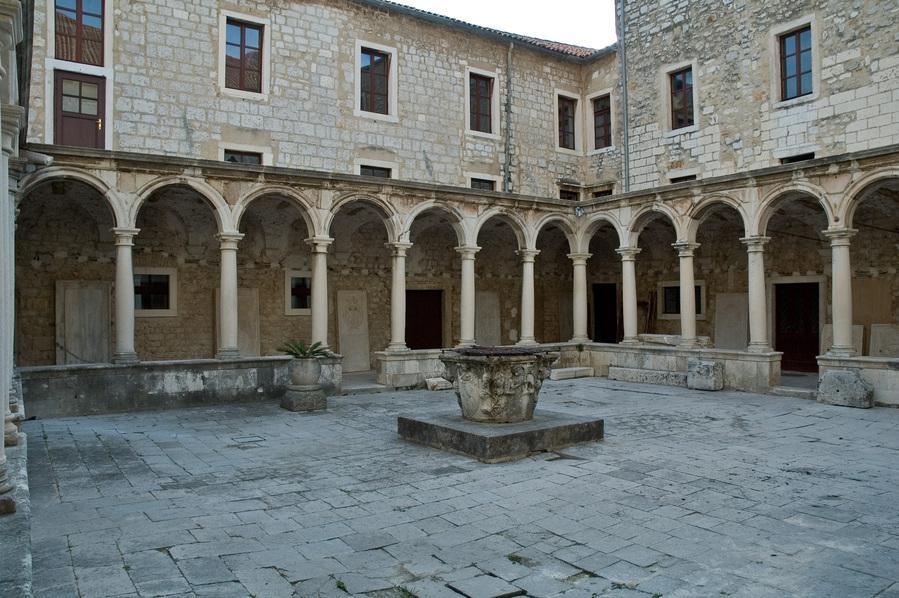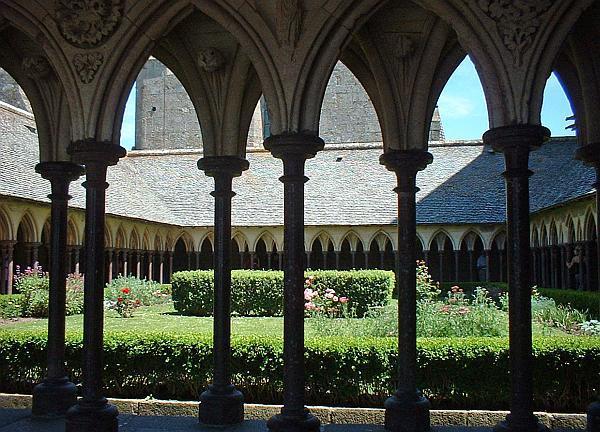The first image is the image on the left, the second image is the image on the right. Given the left and right images, does the statement "A single door can be seen at the end of the corridor in one of the images." hold true? Answer yes or no. No. 